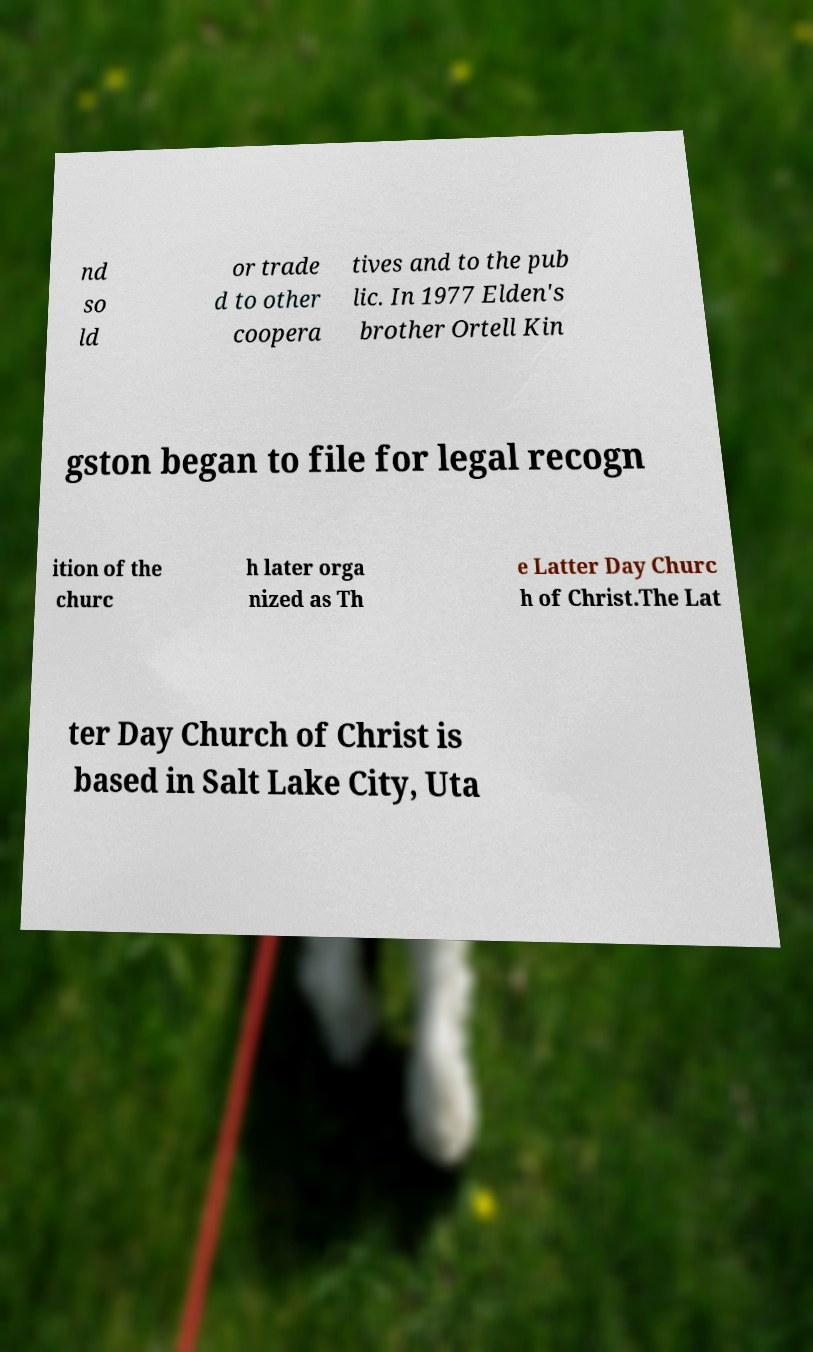Could you assist in decoding the text presented in this image and type it out clearly? nd so ld or trade d to other coopera tives and to the pub lic. In 1977 Elden's brother Ortell Kin gston began to file for legal recogn ition of the churc h later orga nized as Th e Latter Day Churc h of Christ.The Lat ter Day Church of Christ is based in Salt Lake City, Uta 